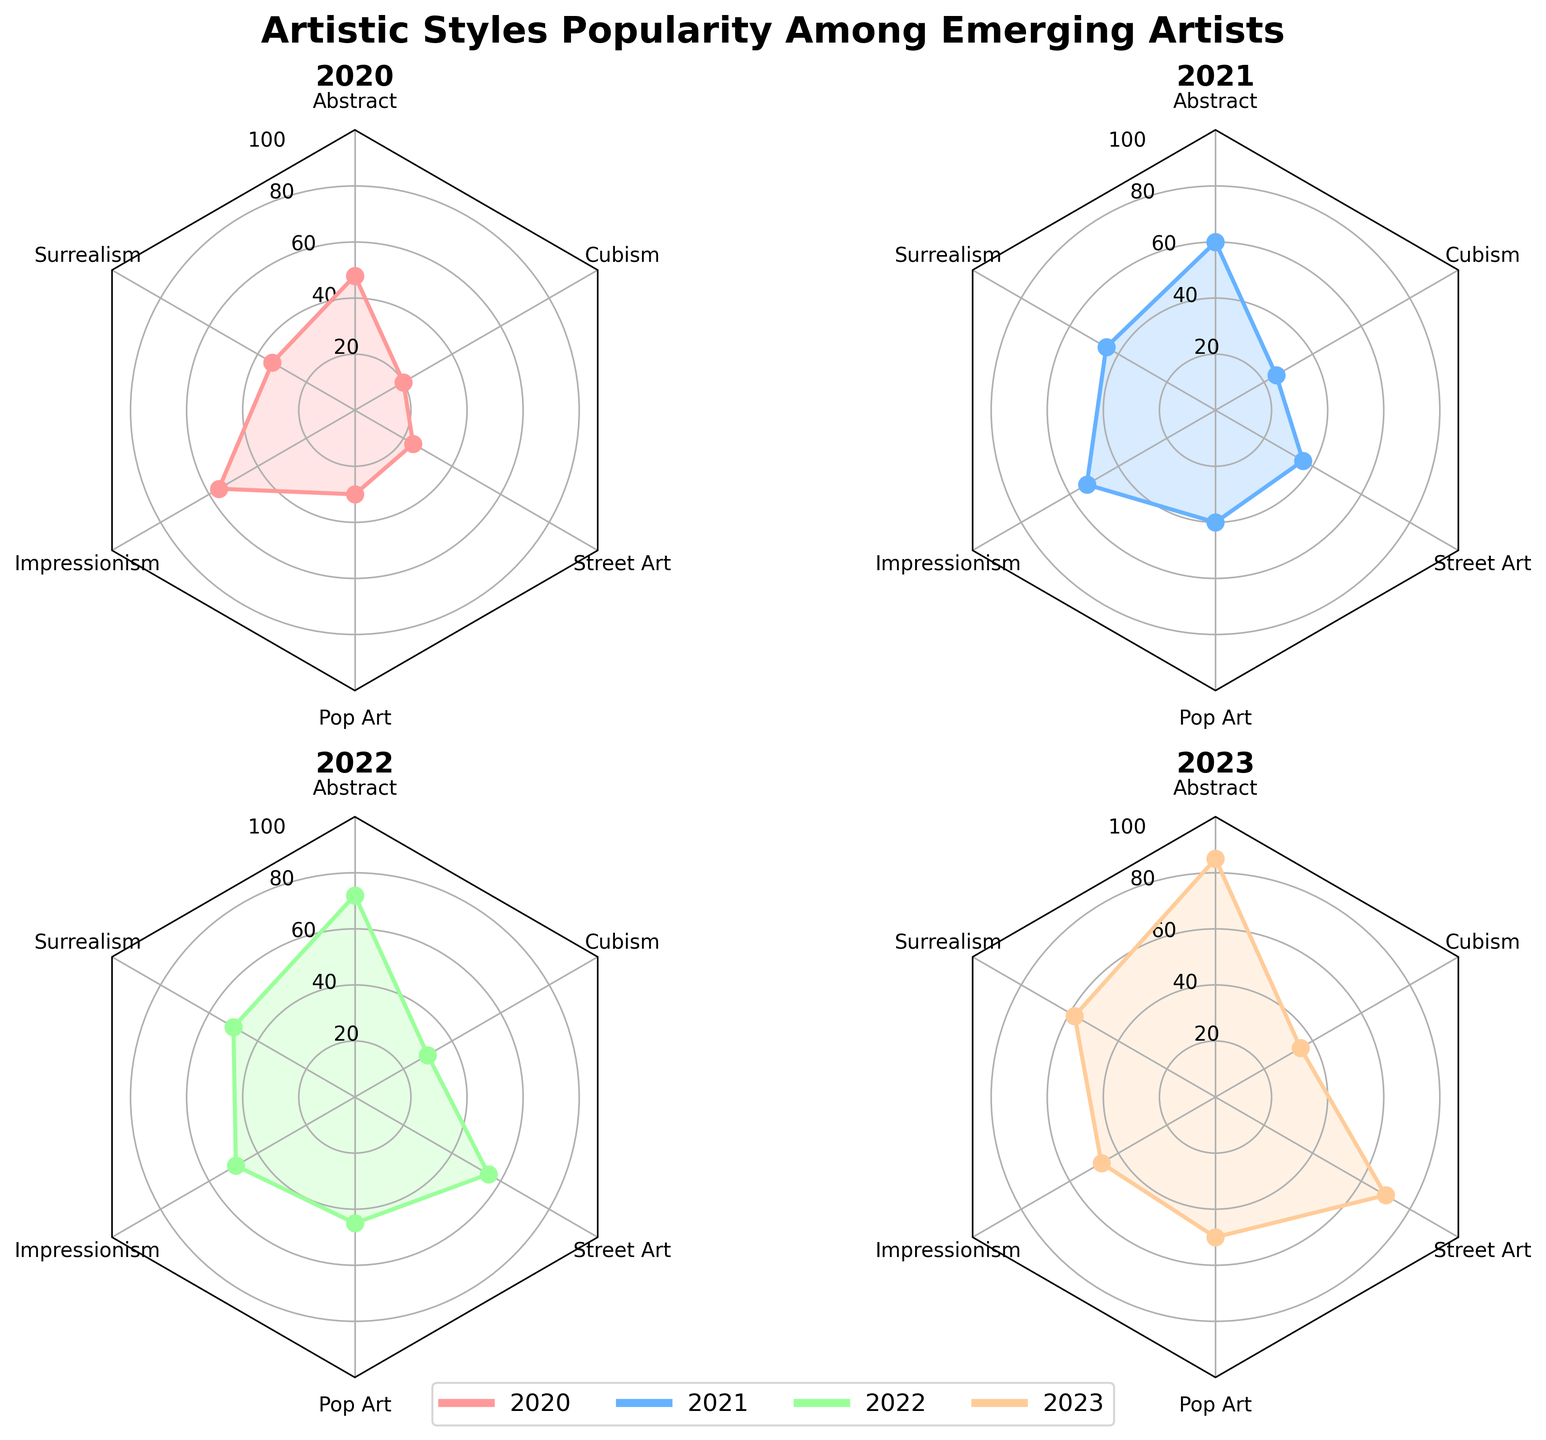Which artistic style experienced the highest increase in popularity from 2020 to 2023? From the radar chart, observe the increase in values for each artistic style over the years. Abstract increased from 48 to 85, Surrealism from 34 to 58, Impressionism decreased from 56 to 47, Pop Art from 30 to 50, Street Art from 24 to 70, and Cubism from 20 to 35. Street Art increased the most by 46 points.
Answer: Street Art What was the popularity of Abstract art in 2021? Locate the 2021 subplot, and look for the value corresponding to Abstract art. The visualized data point is at 60.
Answer: 60 Which year had the highest popularity for Impressionism? Analyze each subplot to find the highest value for Impressionism. The values are 56 (2020), 53 (2021), 49 (2022), and 47 (2023). The highest value is in 2020.
Answer: 2020 Compare the popularity of Surrealism and Cubism in 2023. Which is more popular? Go to the 2023 subplot, and compare the values for Surrealism and Cubism. Surrealism is at 58, and Cubism is at 35. Surrealism is more popular.
Answer: Surrealism What is the overall trend for Pop Art from 2020 to 2023? Observe the trend line for Pop Art across the subplots. The values are 30 (2020), 40 (2021), 45 (2022), and 50 (2023), showing a consistent increase.
Answer: Increasing Which artistic style had the lowest popularity in 2020? In the 2020 subplot, compare the values for each style. Cubism has the lowest value at 20.
Answer: Cubism What is the range of popularity values for Street Art in 2022? In the 2022 subplot, locate the value for Street Art. The radar chart shows it at 55, which is the only needed value since range is only considering this single point.
Answer: 55 Which year saw the least change in street art's popularity compared to the previous year? Evaluate the change for Street Art across the years: 24 (2020), 36 (2021), 55 (2022), and 70 (2023). Calculate the differences: 12 (2021-2020), 19 (2022-2021), 15 (2023-2022). The smallest change is 12 (2021-2020).
Answer: 2021 What was the popularity difference between Abstract and Impressionism in 2022? In the 2022 subplot, locate values for Abstract (72) and Impressionism (49). Calculate the difference: 72 - 49 = 23.
Answer: 23 